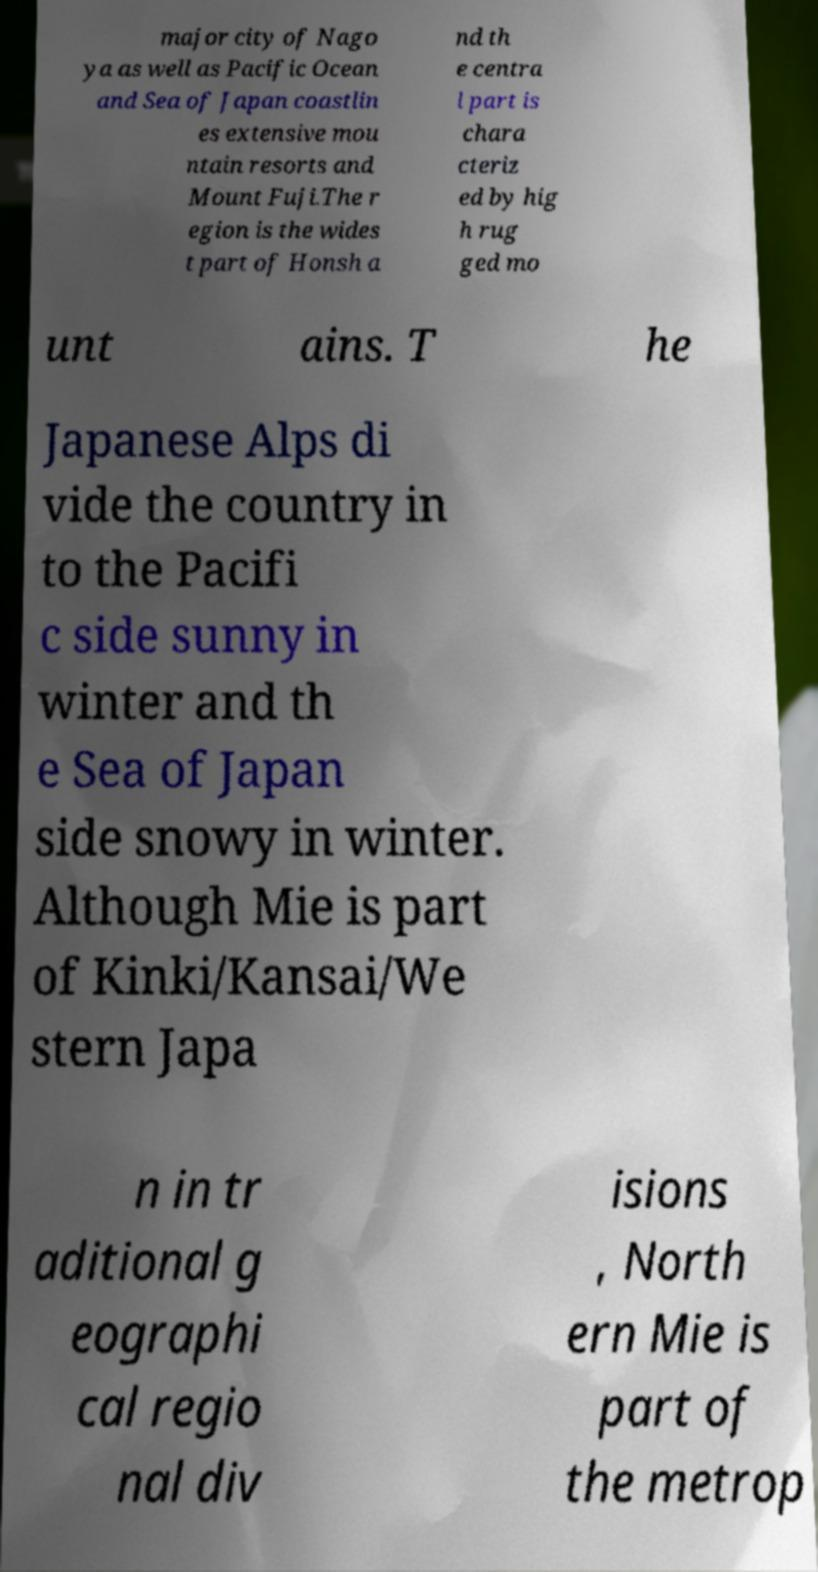Can you read and provide the text displayed in the image?This photo seems to have some interesting text. Can you extract and type it out for me? major city of Nago ya as well as Pacific Ocean and Sea of Japan coastlin es extensive mou ntain resorts and Mount Fuji.The r egion is the wides t part of Honsh a nd th e centra l part is chara cteriz ed by hig h rug ged mo unt ains. T he Japanese Alps di vide the country in to the Pacifi c side sunny in winter and th e Sea of Japan side snowy in winter. Although Mie is part of Kinki/Kansai/We stern Japa n in tr aditional g eographi cal regio nal div isions , North ern Mie is part of the metrop 